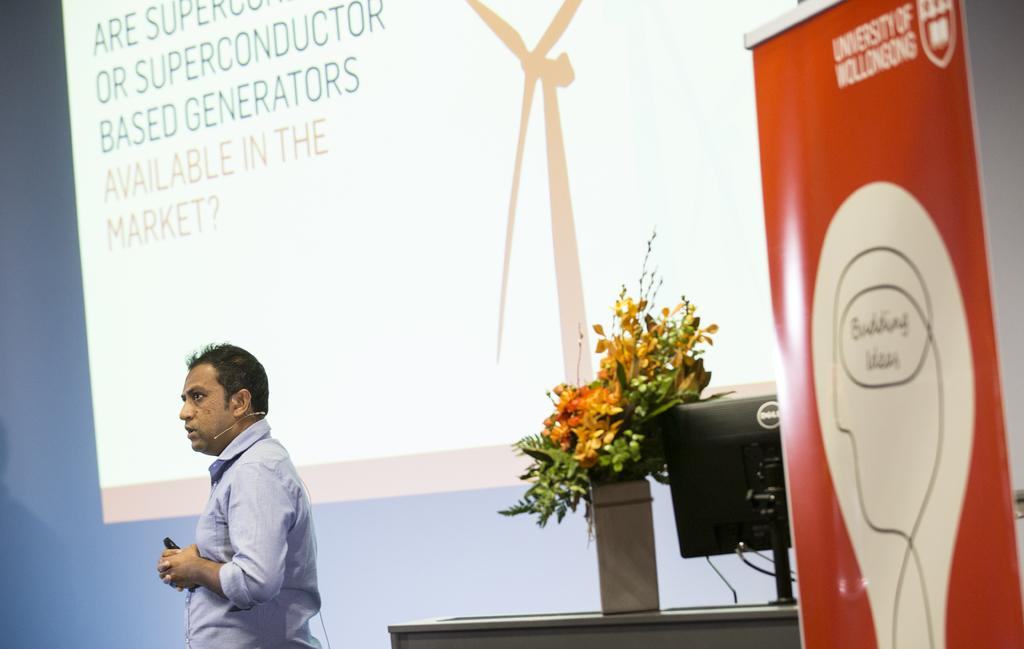Who is in the image? There is a man in the image. What is the man wearing? The man is wearing a blue shirt. What is behind the man in the image? The man is standing in front of a screen. What furniture is present in the image? There is a table in the image. What electronic device is on the table? A computer is present on the table. What decorative item is on the table? There is a flower vase on the table. What additional object is in the image? There is a banner in the image. What historical discovery did the man make while standing in front of the screen? There is no indication of a historical discovery in the image; the man is simply standing in front of a screen. 